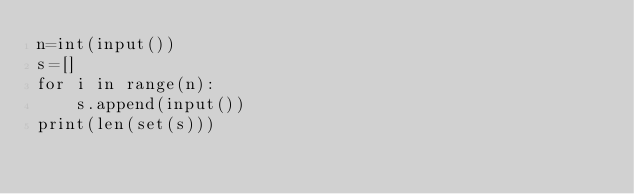<code> <loc_0><loc_0><loc_500><loc_500><_Python_>n=int(input())
s=[]
for i in range(n):
    s.append(input())
print(len(set(s)))</code> 